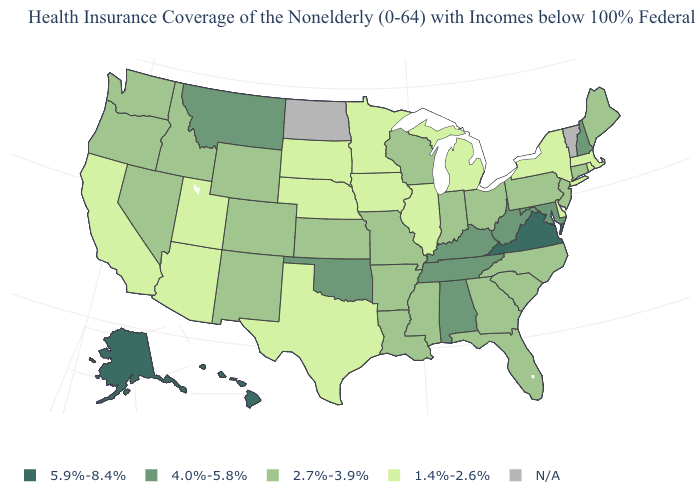Which states have the highest value in the USA?
Keep it brief. Alaska, Hawaii, Virginia. What is the value of Minnesota?
Give a very brief answer. 1.4%-2.6%. What is the value of New Hampshire?
Be succinct. 4.0%-5.8%. What is the value of Alaska?
Be succinct. 5.9%-8.4%. Does Nebraska have the highest value in the MidWest?
Be succinct. No. What is the highest value in the Northeast ?
Keep it brief. 4.0%-5.8%. Name the states that have a value in the range 1.4%-2.6%?
Be succinct. Arizona, California, Delaware, Illinois, Iowa, Massachusetts, Michigan, Minnesota, Nebraska, New York, Rhode Island, South Dakota, Texas, Utah. Name the states that have a value in the range 1.4%-2.6%?
Give a very brief answer. Arizona, California, Delaware, Illinois, Iowa, Massachusetts, Michigan, Minnesota, Nebraska, New York, Rhode Island, South Dakota, Texas, Utah. Does the map have missing data?
Quick response, please. Yes. What is the value of Arkansas?
Give a very brief answer. 2.7%-3.9%. What is the value of Colorado?
Answer briefly. 2.7%-3.9%. Which states have the lowest value in the West?
Be succinct. Arizona, California, Utah. What is the value of Pennsylvania?
Give a very brief answer. 2.7%-3.9%. 